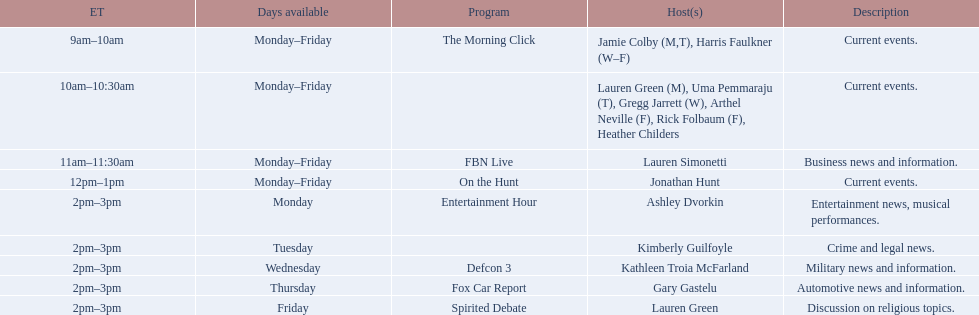Can you list all the host names? Jamie Colby (M,T), Harris Faulkner (W–F), Lauren Green (M), Uma Pemmaraju (T), Gregg Jarrett (W), Arthel Neville (F), Rick Folbaum (F), Heather Childers, Lauren Simonetti, Jonathan Hunt, Ashley Dvorkin, Kimberly Guilfoyle, Kathleen Troia McFarland, Gary Gastelu, Lauren Green. Can you parse all the data within this table? {'header': ['ET', 'Days available', 'Program', 'Host(s)', 'Description'], 'rows': [['9am–10am', 'Monday–Friday', 'The Morning Click', 'Jamie Colby (M,T), Harris Faulkner (W–F)', 'Current events.'], ['10am–10:30am', 'Monday–Friday', '', 'Lauren Green (M), Uma Pemmaraju (T), Gregg Jarrett (W), Arthel Neville (F), Rick Folbaum (F), Heather Childers', 'Current events.'], ['11am–11:30am', 'Monday–Friday', 'FBN Live', 'Lauren Simonetti', 'Business news and information.'], ['12pm–1pm', 'Monday–Friday', 'On the Hunt', 'Jonathan Hunt', 'Current events.'], ['2pm–3pm', 'Monday', 'Entertainment Hour', 'Ashley Dvorkin', 'Entertainment news, musical performances.'], ['2pm–3pm', 'Tuesday', '', 'Kimberly Guilfoyle', 'Crime and legal news.'], ['2pm–3pm', 'Wednesday', 'Defcon 3', 'Kathleen Troia McFarland', 'Military news and information.'], ['2pm–3pm', 'Thursday', 'Fox Car Report', 'Gary Gastelu', 'Automotive news and information.'], ['2pm–3pm', 'Friday', 'Spirited Debate', 'Lauren Green', 'Discussion on religious topics.']]} Which of these hosts have a show on fridays? Jamie Colby (M,T), Harris Faulkner (W–F), Lauren Green (M), Uma Pemmaraju (T), Gregg Jarrett (W), Arthel Neville (F), Rick Folbaum (F), Heather Childers, Lauren Simonetti, Jonathan Hunt, Lauren Green. Out of these, who has only friday as their available day? Lauren Green. 